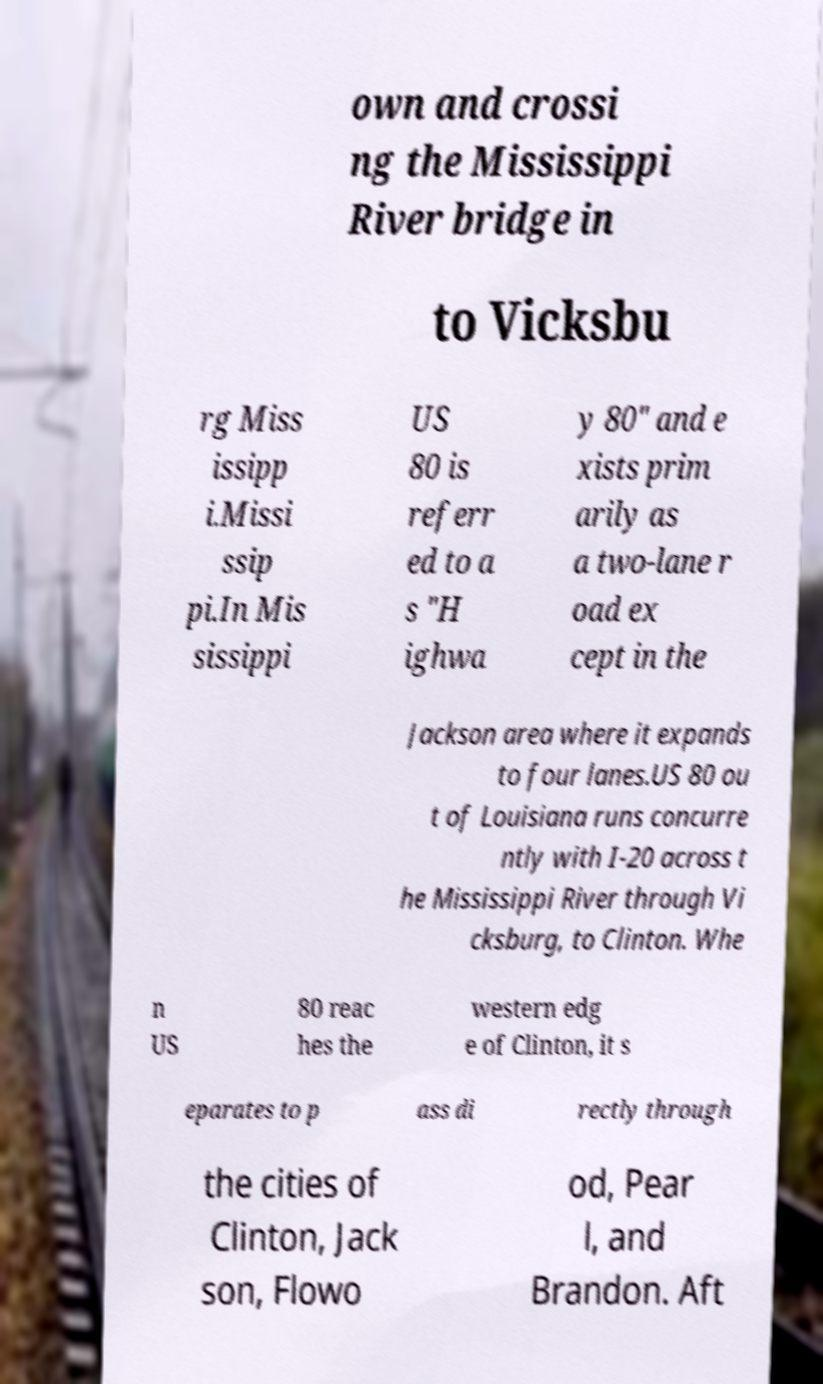Please identify and transcribe the text found in this image. own and crossi ng the Mississippi River bridge in to Vicksbu rg Miss issipp i.Missi ssip pi.In Mis sissippi US 80 is referr ed to a s "H ighwa y 80" and e xists prim arily as a two-lane r oad ex cept in the Jackson area where it expands to four lanes.US 80 ou t of Louisiana runs concurre ntly with I-20 across t he Mississippi River through Vi cksburg, to Clinton. Whe n US 80 reac hes the western edg e of Clinton, it s eparates to p ass di rectly through the cities of Clinton, Jack son, Flowo od, Pear l, and Brandon. Aft 